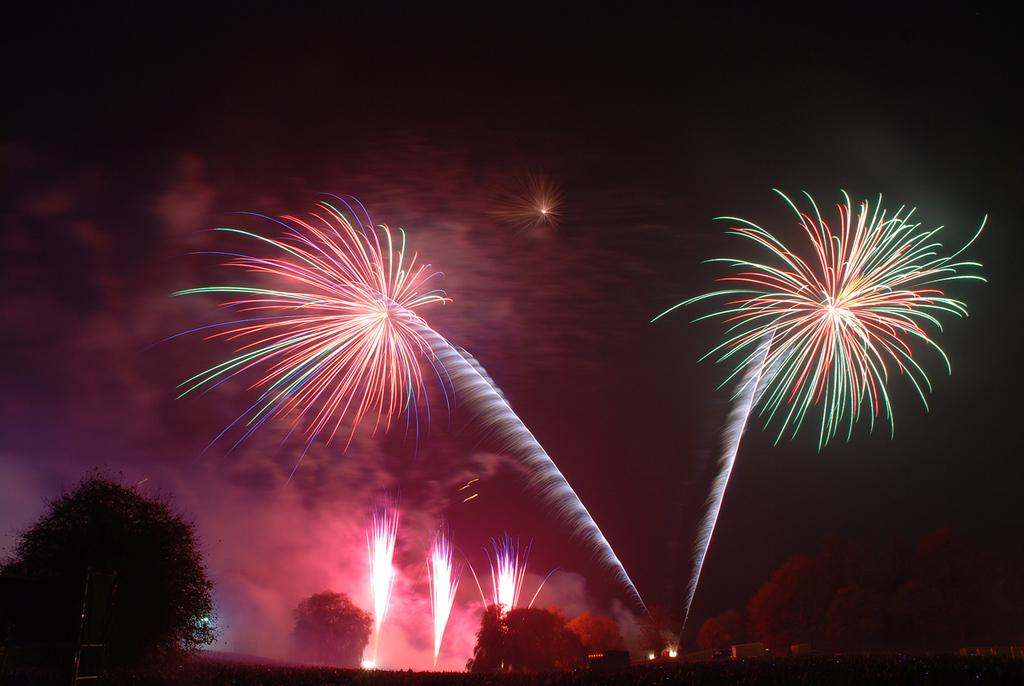What is happening in the sky in the image? There are many firecrackers in the sky in the image. What can be seen at the bottom of the image? There are trees and buildings visible at the bottom of the image. What is visible at the top of the image? The sky is visible at the top of the image. Can you describe the darkness in the top right corner of the image? There is a darkness in the top right corner of the image. How far away is the leather from the heart in the image? There is no leather or heart present in the image. 